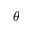Convert formula to latex. <formula><loc_0><loc_0><loc_500><loc_500>\theta</formula> 